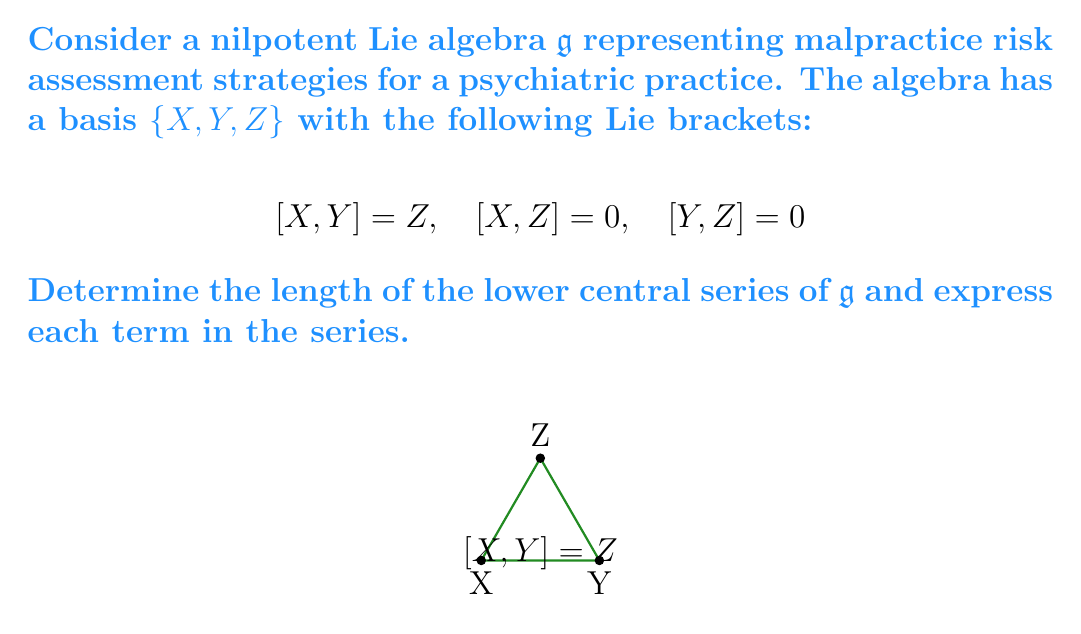Can you solve this math problem? Let's approach this step-by-step:

1) Recall that the lower central series of a Lie algebra $\mathfrak{g}$ is defined as:
   $$\mathfrak{g} = \mathfrak{g}^1 \supset \mathfrak{g}^2 \supset \mathfrak{g}^3 \supset \cdots$$
   where $\mathfrak{g}^{i+1} = [\mathfrak{g}, \mathfrak{g}^i]$

2) Let's compute each term:

   $\mathfrak{g}^1 = \mathfrak{g} = \text{span}\{X, Y, Z\}$

3) $\mathfrak{g}^2 = [\mathfrak{g}, \mathfrak{g}^1]$:
   $[X,X] = 0$
   $[X,Y] = Z$
   $[X,Z] = 0$
   $[Y,Y] = 0$
   $[Y,Z] = 0$
   $[Z,Z] = 0$
   Therefore, $\mathfrak{g}^2 = \text{span}\{Z\}$

4) $\mathfrak{g}^3 = [\mathfrak{g}, \mathfrak{g}^2]$:
   $[X,Z] = 0$
   $[Y,Z] = 0$
   $[Z,Z] = 0$
   Therefore, $\mathfrak{g}^3 = \{0\}$

5) The series terminates at $\mathfrak{g}^3$ as it reaches the zero subspace.

6) The length of the lower central series is the smallest $k$ such that $\mathfrak{g}^k = \{0\}$. In this case, $k = 3$.
Answer: Length: 3. Series: $\mathfrak{g}^1 = \text{span}\{X, Y, Z\}$, $\mathfrak{g}^2 = \text{span}\{Z\}$, $\mathfrak{g}^3 = \{0\}$ 